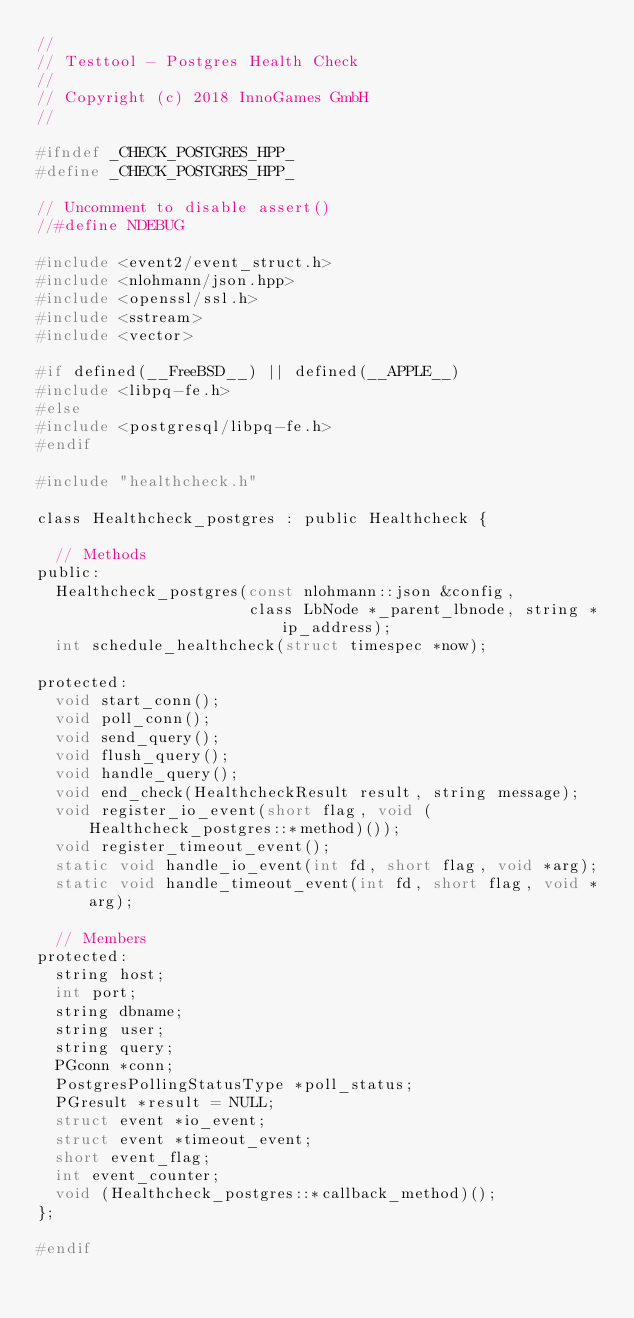<code> <loc_0><loc_0><loc_500><loc_500><_C_>//
// Testtool - Postgres Health Check
//
// Copyright (c) 2018 InnoGames GmbH
//

#ifndef _CHECK_POSTGRES_HPP_
#define _CHECK_POSTGRES_HPP_

// Uncomment to disable assert()
//#define NDEBUG

#include <event2/event_struct.h>
#include <nlohmann/json.hpp>
#include <openssl/ssl.h>
#include <sstream>
#include <vector>

#if defined(__FreeBSD__) || defined(__APPLE__)
#include <libpq-fe.h>
#else
#include <postgresql/libpq-fe.h>
#endif

#include "healthcheck.h"

class Healthcheck_postgres : public Healthcheck {

  // Methods
public:
  Healthcheck_postgres(const nlohmann::json &config,
                       class LbNode *_parent_lbnode, string *ip_address);
  int schedule_healthcheck(struct timespec *now);

protected:
  void start_conn();
  void poll_conn();
  void send_query();
  void flush_query();
  void handle_query();
  void end_check(HealthcheckResult result, string message);
  void register_io_event(short flag, void (Healthcheck_postgres::*method)());
  void register_timeout_event();
  static void handle_io_event(int fd, short flag, void *arg);
  static void handle_timeout_event(int fd, short flag, void *arg);

  // Members
protected:
  string host;
  int port;
  string dbname;
  string user;
  string query;
  PGconn *conn;
  PostgresPollingStatusType *poll_status;
  PGresult *result = NULL;
  struct event *io_event;
  struct event *timeout_event;
  short event_flag;
  int event_counter;
  void (Healthcheck_postgres::*callback_method)();
};

#endif
</code> 